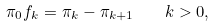Convert formula to latex. <formula><loc_0><loc_0><loc_500><loc_500>\pi _ { 0 } f _ { k } = \pi _ { k } - \pi _ { k + 1 } \quad k > 0 ,</formula> 